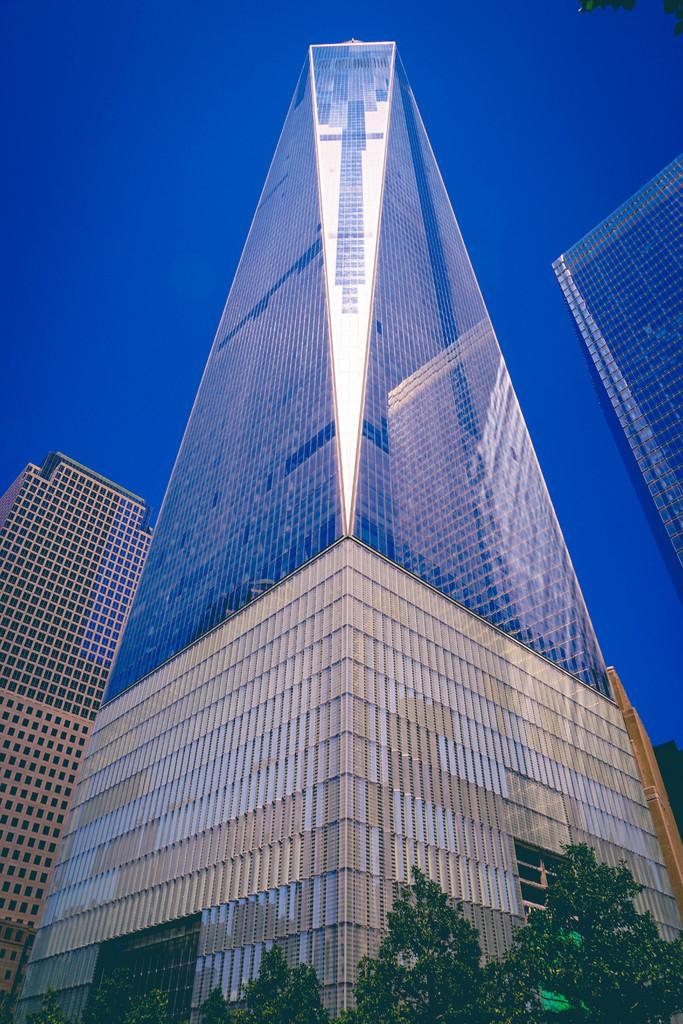What type of buildings can be seen in the image? There are buildings with glass walls in the image. What other elements can be found at the bottom of the image? Trees are present at the bottom of the image. What can be seen in the background of the image? The sky is visible in the background of the image. What type of crayon is being used by the secretary in the image? There is no secretary or crayon present in the image. What type of tools might a carpenter be using in the image? There is no carpenter or tools present in the image. 